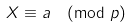Convert formula to latex. <formula><loc_0><loc_0><loc_500><loc_500>X \equiv a { \pmod { p } }</formula> 